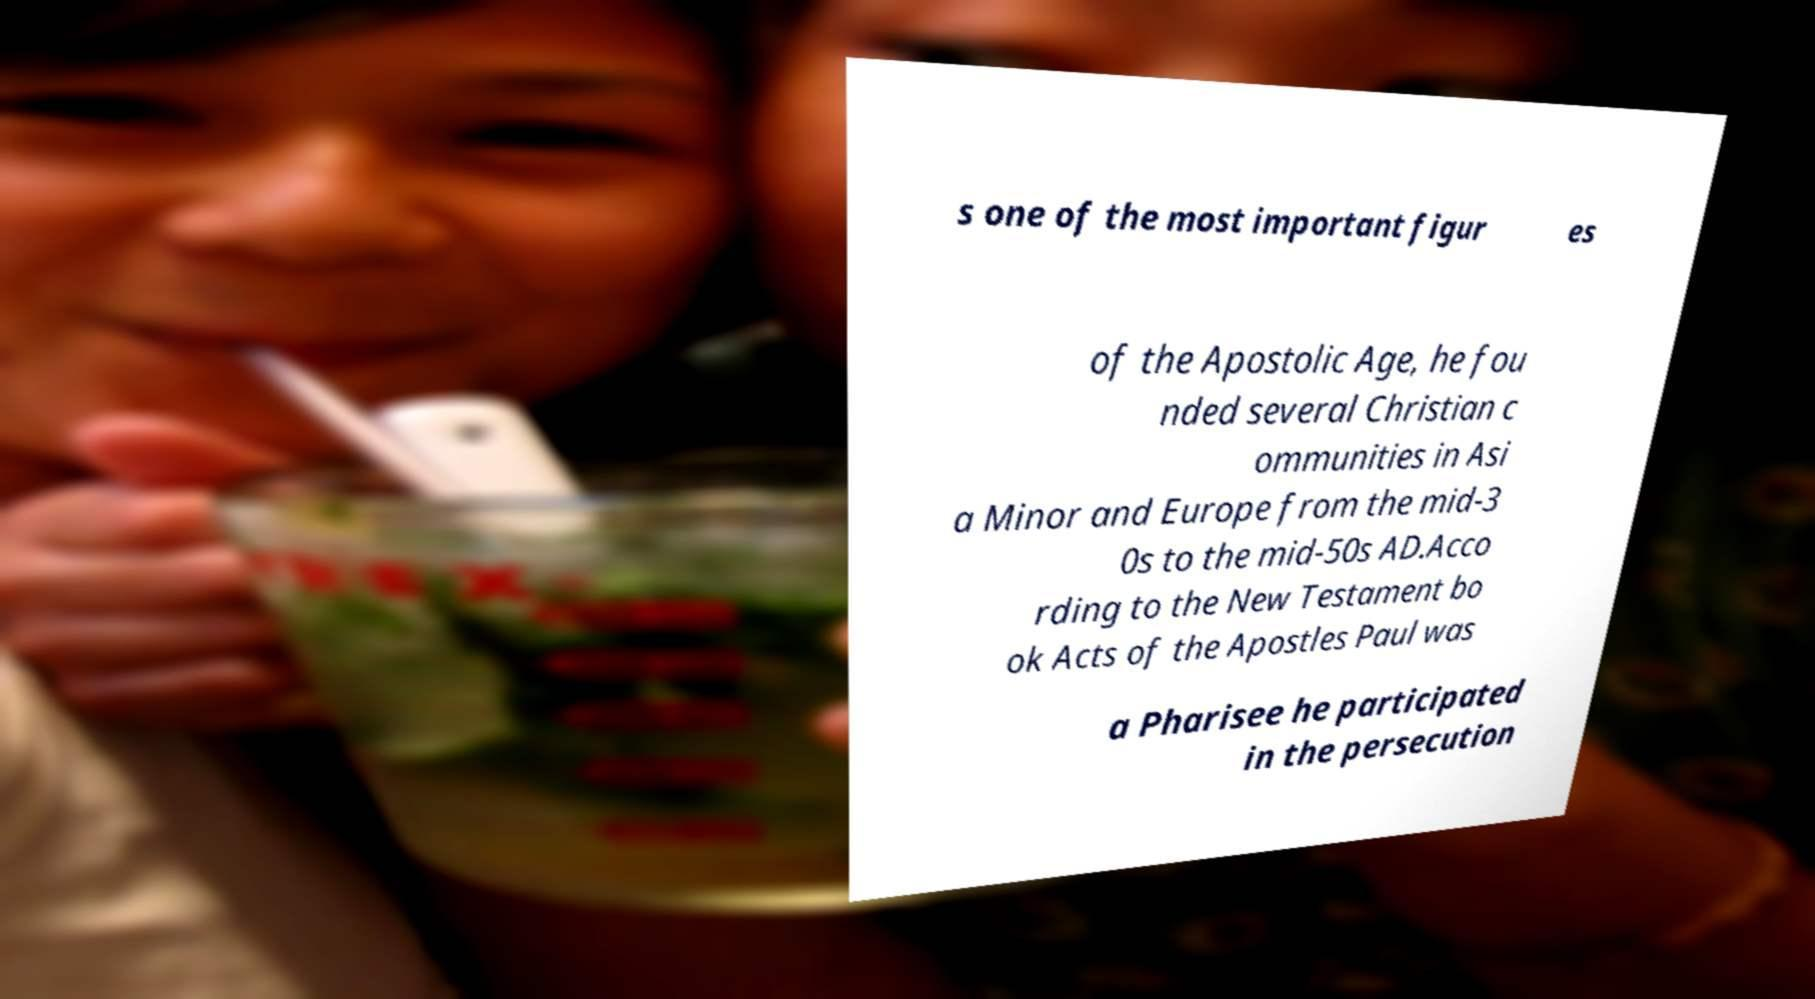Could you assist in decoding the text presented in this image and type it out clearly? s one of the most important figur es of the Apostolic Age, he fou nded several Christian c ommunities in Asi a Minor and Europe from the mid-3 0s to the mid-50s AD.Acco rding to the New Testament bo ok Acts of the Apostles Paul was a Pharisee he participated in the persecution 